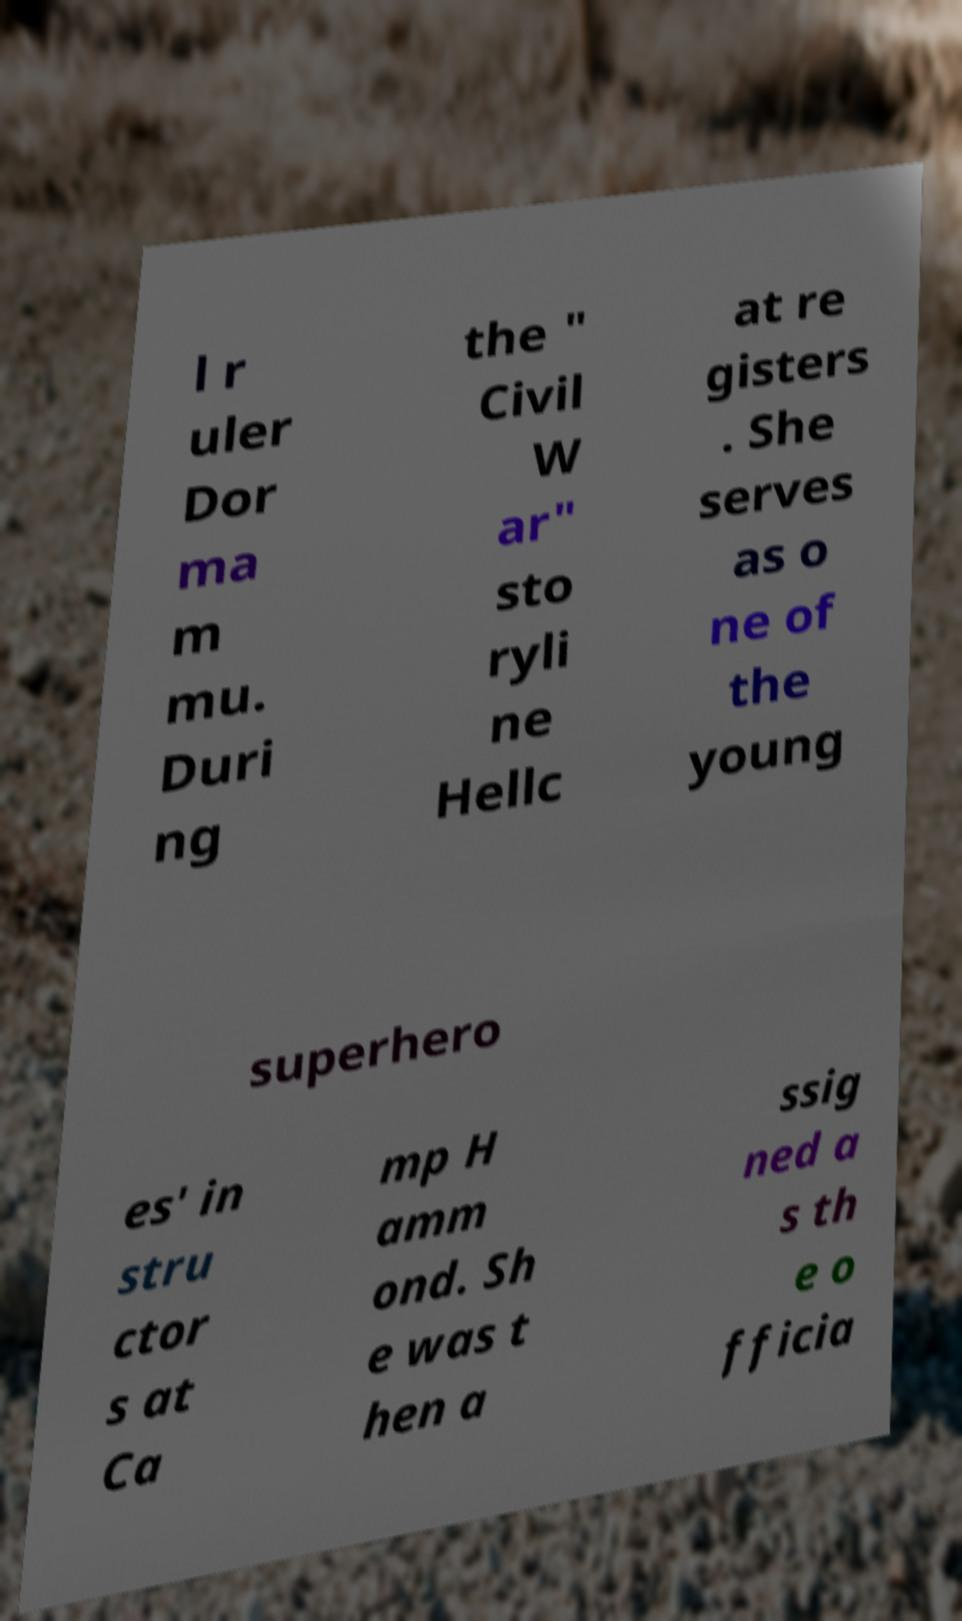I need the written content from this picture converted into text. Can you do that? l r uler Dor ma m mu. Duri ng the " Civil W ar" sto ryli ne Hellc at re gisters . She serves as o ne of the young superhero es' in stru ctor s at Ca mp H amm ond. Sh e was t hen a ssig ned a s th e o fficia 